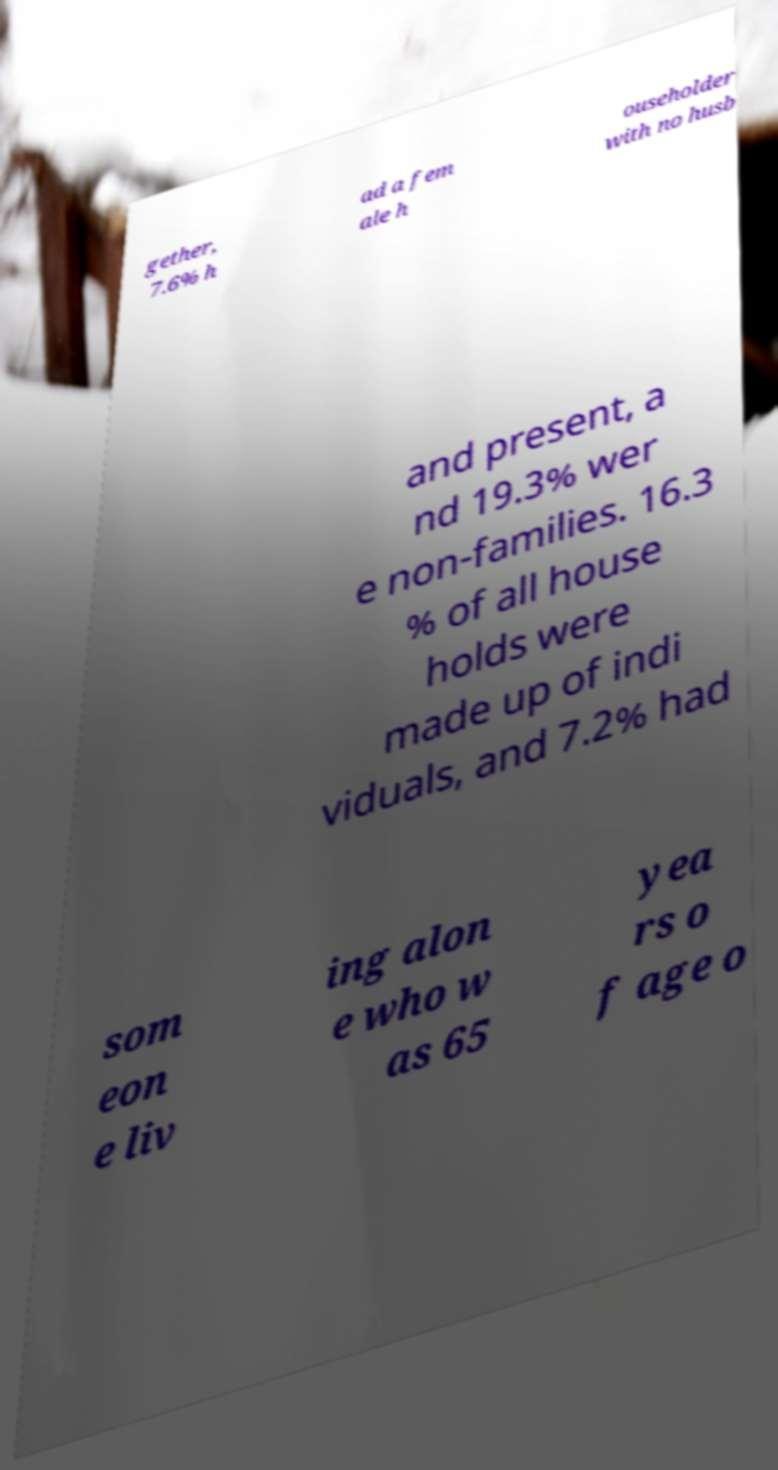Can you accurately transcribe the text from the provided image for me? gether, 7.6% h ad a fem ale h ouseholder with no husb and present, a nd 19.3% wer e non-families. 16.3 % of all house holds were made up of indi viduals, and 7.2% had som eon e liv ing alon e who w as 65 yea rs o f age o 